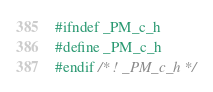<code> <loc_0><loc_0><loc_500><loc_500><_C_>#ifndef _PM_c_h
#define _PM_c_h
#endif /* ! _PM_c_h */
</code> 